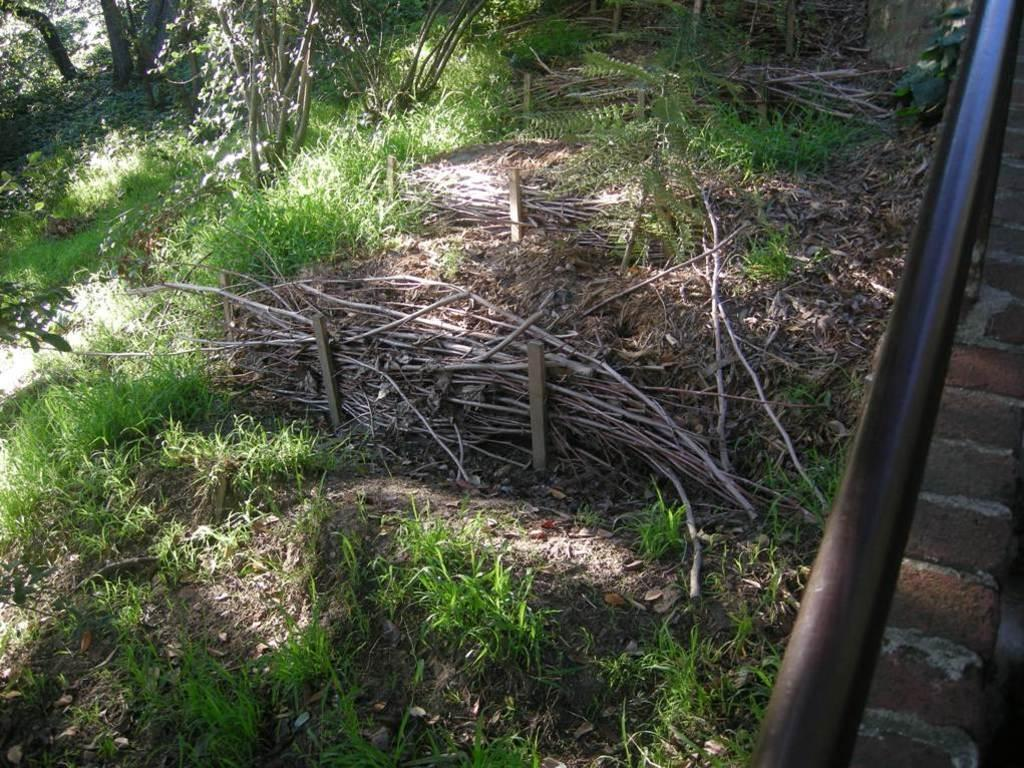What type of living organisms can be seen in the image? Plants are visible in the image. What material is used for some of the objects in the image? Wooden objects are present in the image. Can you describe the unspecified "few things" in the image? Unfortunately, the facts do not provide any details about the "few things" in the image. What is located on the right side of the image? There is a rod and a brick wall on the right side of the image. What type of art can be seen on the brick wall in the image? There is no art visible on the brick wall in the image. Can you tell me how many cats are present in the image? There are no cats present in the image. 